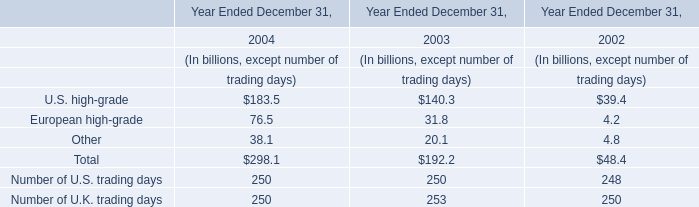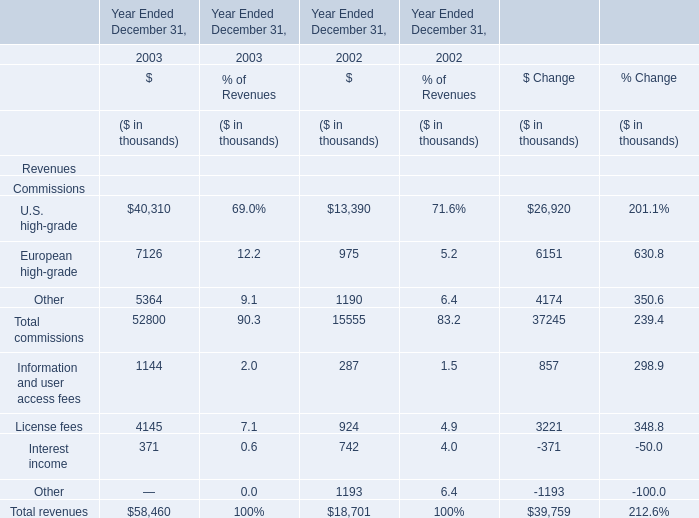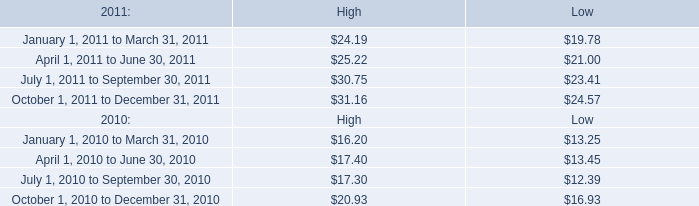What is the sum of European high-grade and U.S. high-grade in 2003? (in thousand) 
Computations: (40310 + 7126)
Answer: 47436.0. during 2010 and 2011 what were total quarterly cash dividends per share? 
Computations: (0.07 + 0.09)
Answer: 0.16. 